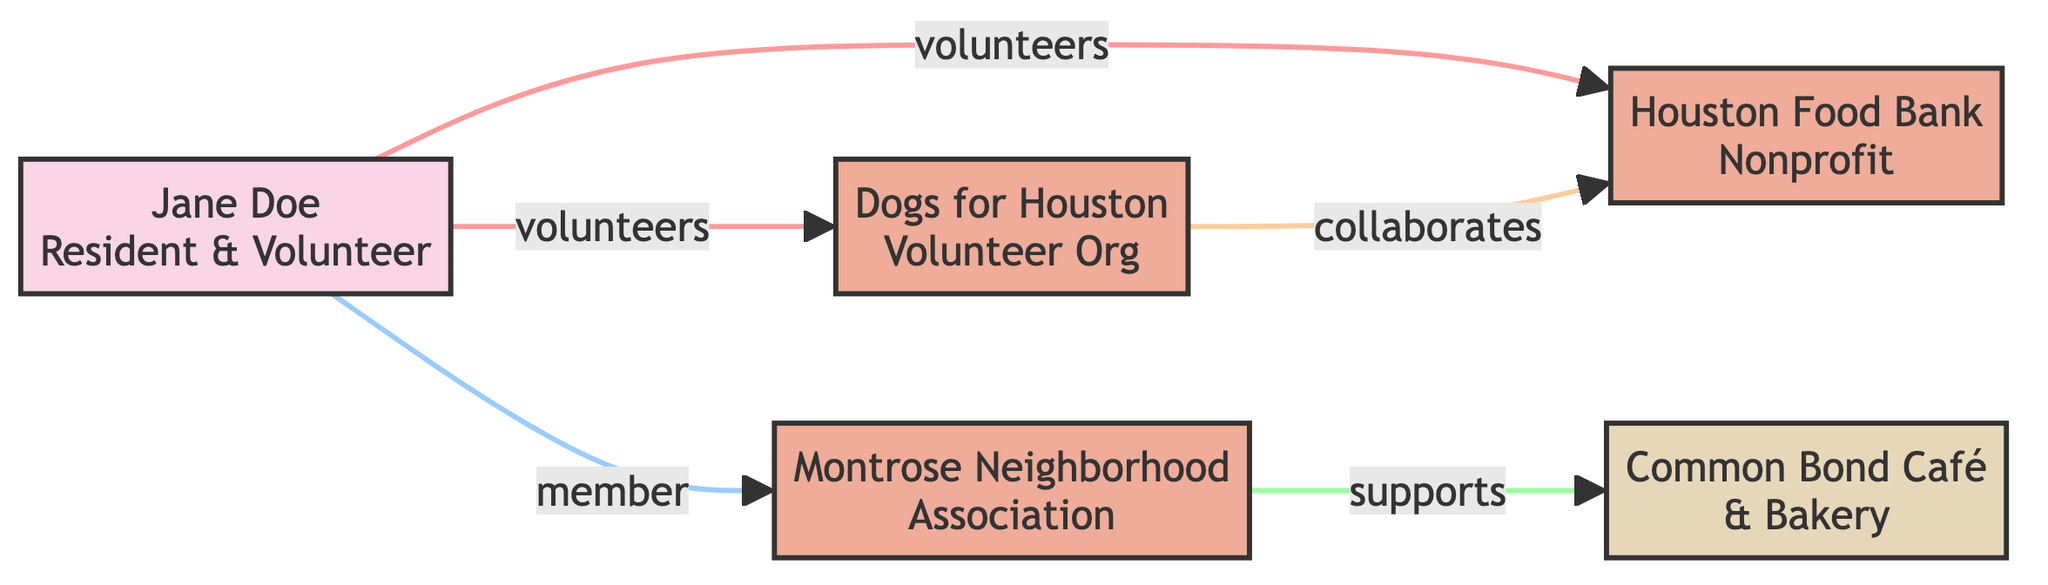What is the total number of nodes in the diagram? Count all entities represented in the diagram: Jane Doe, Houston Food Bank, Montrose Neighborhood Association, Common Bond Café & Bakery, and Dogs for Houston. This gives us a total of 5 nodes.
Answer: 5 Who does Jane Doe volunteer for? Look at the edges connected to Jane Doe. There are two edges labeled "volunteers," one pointing to Houston Food Bank and another pointing to Dogs for Houston. Both indicate that Jane Doe volunteers for these organizations.
Answer: Houston Food Bank, Dogs for Houston What type of organization is the Montrose Neighborhood Association? The diagram indicates that the Montrose Neighborhood Association is categorized under "organization" in its definition.
Answer: organization How many different types of nodes are present in the diagram? Identify the types of nodes: individual, organization, and business. This gives us three different types of nodes in the diagram.
Answer: 3 Which organization collaborates with the Houston Food Bank? The edge labeled "collaborates" connects Dogs for Houston to the Houston Food Bank, indicating that this is the organization that collaborates with it.
Answer: Dogs for Houston What support does Common Bond Café & Bakery provide? The edge connecting the Montrose Neighborhood Association to Common Bond Café & Bakery is labeled "supports." This indicates that the café supports the events organized by the neighborhood association.
Answer: supports Montrose Neighborhood Association events Who is a member of the Montrose Neighborhood Association? Refer to the edge that shows the relationship between Jane Doe and the Montrose Neighborhood Association. It is explicitly labeled "member," indicating that Jane Doe is a member.
Answer: Jane Doe What type of business is Common Bond Café & Bakery? According to its description in the diagram, Common Bond Café & Bakery is identified as a local bakery.
Answer: local bakery What is the relationship between Dogs for Houston and Houston Food Bank? The diagram indicates a relationship labeled "collaborates" between Dogs for Houston and Houston Food Bank, showing they work together for joint events.
Answer: collaborates 